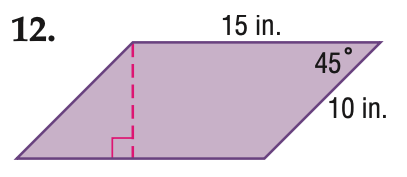Answer the mathemtical geometry problem and directly provide the correct option letter.
Question: Find the area of the parallelogram. Round to the nearest tenth if necessary.
Choices: A: 75 B: 106.1 C: 150 D: 212.1 B 